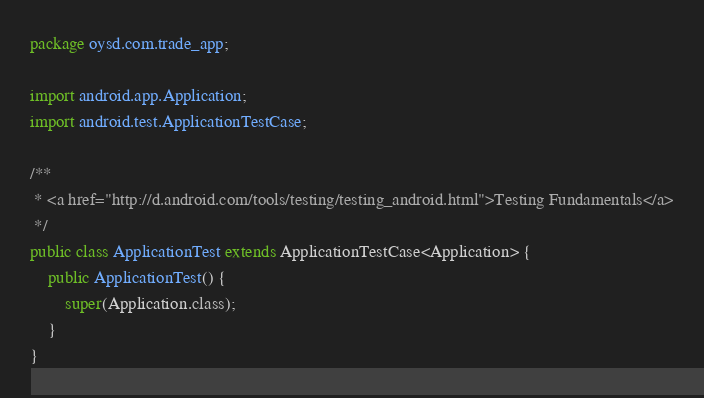Convert code to text. <code><loc_0><loc_0><loc_500><loc_500><_Java_>package oysd.com.trade_app;

import android.app.Application;
import android.test.ApplicationTestCase;

/**
 * <a href="http://d.android.com/tools/testing/testing_android.html">Testing Fundamentals</a>
 */
public class ApplicationTest extends ApplicationTestCase<Application> {
    public ApplicationTest() {
        super(Application.class);
    }
}</code> 